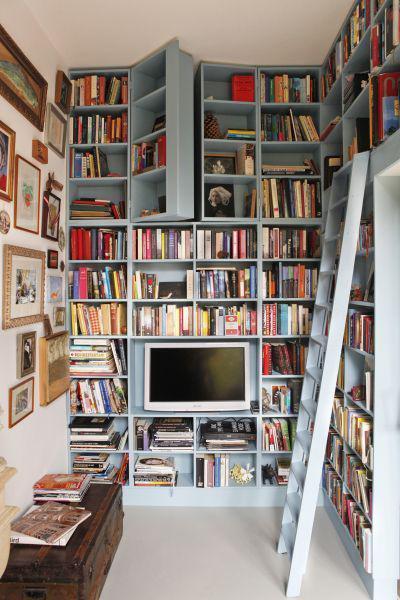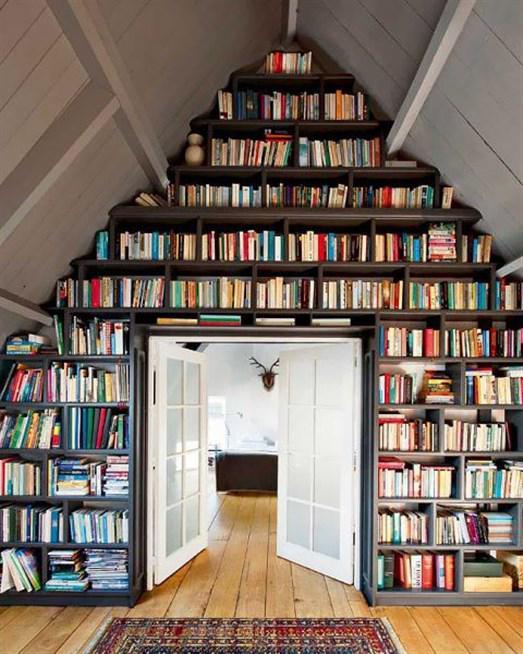The first image is the image on the left, the second image is the image on the right. Analyze the images presented: Is the assertion "there is a built in bookcase with white molding and molding on half the wall around it" valid? Answer yes or no. No. The first image is the image on the left, the second image is the image on the right. Analyze the images presented: Is the assertion "One of the bookshelves has wooden cabinet doors at the bottom." valid? Answer yes or no. No. 